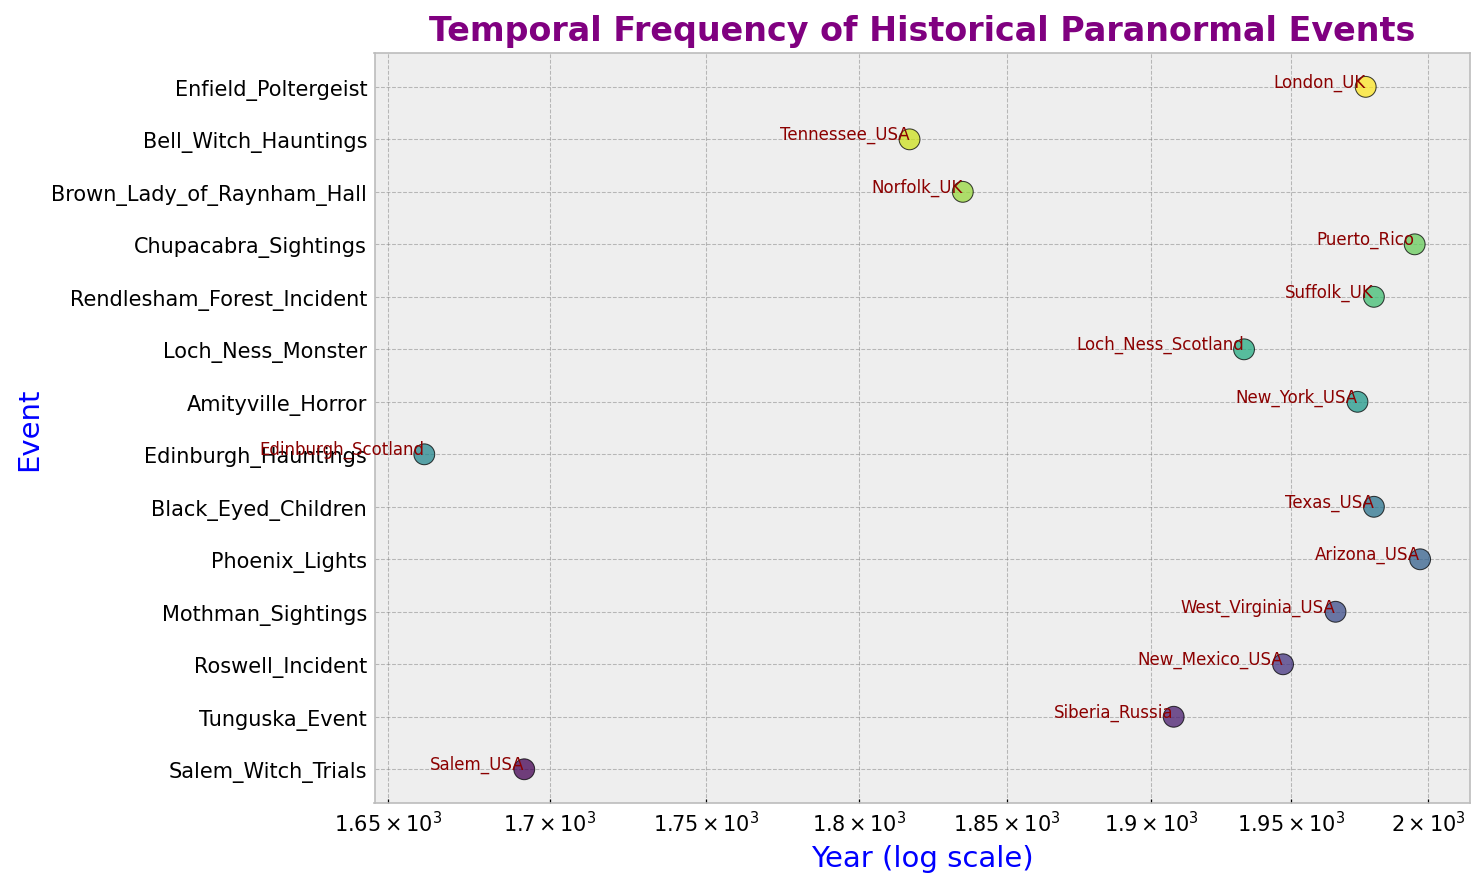What is the latest event shown on the plot? The plot uses a log scale on the x-axis for years. By observing the rightmost data point, we see that the latest event is the Phoenix Lights in Arizona, USA, which occurred in 1997.
Answer: Phoenix Lights Between the Loch Ness Monster sightings and the Black Eyed Children sightings, which event happened earlier? Both events are plotted on the log-scaled x-axis for years. The Loch Ness Monster sightings are located toward the left compared to the Black Eyed Children sightings, indicating they happened earlier in 1933, while the Black Eyed Children sightings occurred in 1980.
Answer: Loch Ness Monster Which geographic location appears most frequently in the plot? By looking at the text annotations beside each event in the scatter plot, we can count the occurrence of each location. USA appears most frequently with multiple events such as Salem, New Mexico, West Virginia, Texas, New York, and Tennessee.
Answer: USA How many events occurred before the 20th century? Checking the scatter plot for all events before the year 1900 (extending from the left end up to ~1900 mark in the log scale), we find the Salem Witch Trials (1692), Edinburgh Hauntings (1661), Brown Lady of Raynham Hall (1835), and Bell Witch Hauntings (1817), making a total of 4 events.
Answer: 4 What is the second most recent event listed in the plot? To determine this, we order the events from the latest to oldest based on the x-coordinates. The second most recent event is the Chupacabra Sightings in Puerto Rico, which occurred in 1995.
Answer: Chupacabra Sightings Which event's geographic location is plotted furthest to the left? By observing the leftmost data point on the log-scaled x-axis for years, we find that the earliest event is the Edinburgh Hauntings in Edinburgh, Scotland, which occurred in 1661.
Answer: Edinburgh Hauntings Compare the number of events in the USA and the UK; which one has more events? By reading the geographic location annotations, we can count the occurrences for each country. The USA has Salem Witch Trials, Roswell Incident, Mothman Sightings, Phoenix Lights, Black Eyed Children, Amityville Horror, Bell Witch Hauntings, and Enfield Poltergeist, totaling 8 events. The UK has Rendlesham Forest Incident, Brown Lady of Raynham Hall, and Enfield Poltergeist, totaling 3 events. The USA has more events.
Answer: USA What is the average year of the paranormal events that occurred in the USA? To find the average, we list the years of the events in the USA: 1692, 1947, 1966, 1997, 1980, 1974, 1817. Summing these gives 11173. Dividing by 7 (the number of events) gives an average year of ~1596.
Answer: 1600 